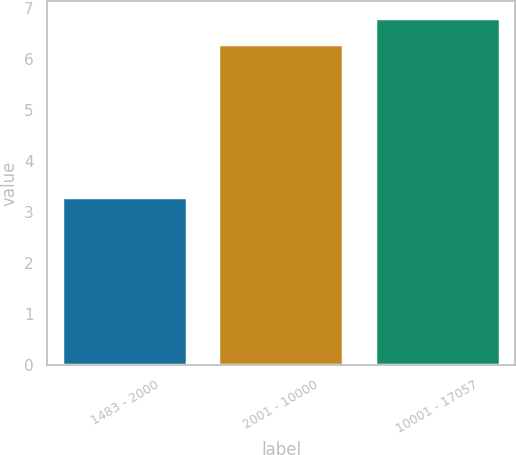Convert chart to OTSL. <chart><loc_0><loc_0><loc_500><loc_500><bar_chart><fcel>1483 - 2000<fcel>2001 - 10000<fcel>10001 - 17057<nl><fcel>3.3<fcel>6.3<fcel>6.8<nl></chart> 